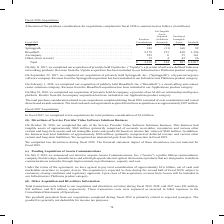According to Cisco Systems's financial document, What was the amount of Purchased Considerations for BroadSoft? According to the financial document, 2,179 (in millions). The relevant text states: "80 $ 335 Springpath . 248 (11) 160 99 BroadSoft . 2,179 353 430 1,396 Accompany . 222 6 55 161 Others (four in total) . 72 4 42 26 Total . $ 3,218 $ 334 $..." Also, What was the amount of Purchased Intangible Assets for Springpath? According to the financial document, 160 (in millions). The relevant text states: ". $ 497 $ (18) $ 180 $ 335 Springpath . 248 (11) 160 99 BroadSoft . 2,179 353 430 1,396 Accompany . 222 6 55 161 Others (four in total) . 72 4 42 26 Tot..." Also, What were the companies acquired in 2017? The document shows two values: Viptela Inc. (“Viptela”) and Springpath, Inc. (“Springpath”). From the document: "17, we completed our acquisition of privately held Viptela Inc. (“Viptela”), a provider of software-defined wide area networking products. Revenue fro..." Also, can you calculate: What was the difference in Purchase Consideration between Springpath and Broadsoft? Based on the calculation: 2,179-248, the result is 1931 (in millions). This is based on the information: "l Viptela . $ 497 $ (18) $ 180 $ 335 Springpath . 248 (11) 160 99 BroadSoft . 2,179 353 430 1,396 Accompany . 222 6 55 161 Others (four in total) . 72 4 80 $ 335 Springpath . 248 (11) 160 99 BroadSoft..." The key data points involved are: 2,179, 248. Also, can you calculate: What was Goodwill from Others companies as a percentage of total Goodwill? Based on the calculation: 26/2,017, the result is 1.29 (percentage). This is based on the information: "y . 222 6 55 161 Others (four in total) . 72 4 42 26 Total . $ 3,218 $ 334 $ 867 $ 2,017 total) . 72 4 42 26 Total . $ 3,218 $ 334 $ 867 $ 2,017..." The key data points involved are: 2,017, 26. Also, can you calculate: What was the difference in Purchased Intangible Assets between Viptela and Springpath? Based on the calculation: 180-160, the result is 20 (in millions). This is based on the information: ". $ 497 $ (18) $ 180 $ 335 Springpath . 248 (11) 160 99 BroadSoft . 2,179 353 430 1,396 Accompany . 222 6 55 161 Others (four in total) . 72 4 42 26 Tot tangible Assets Goodwill Viptela . $ 497 $ (18)..." The key data points involved are: 160, 180. 